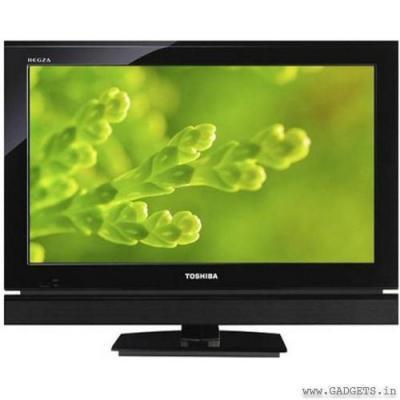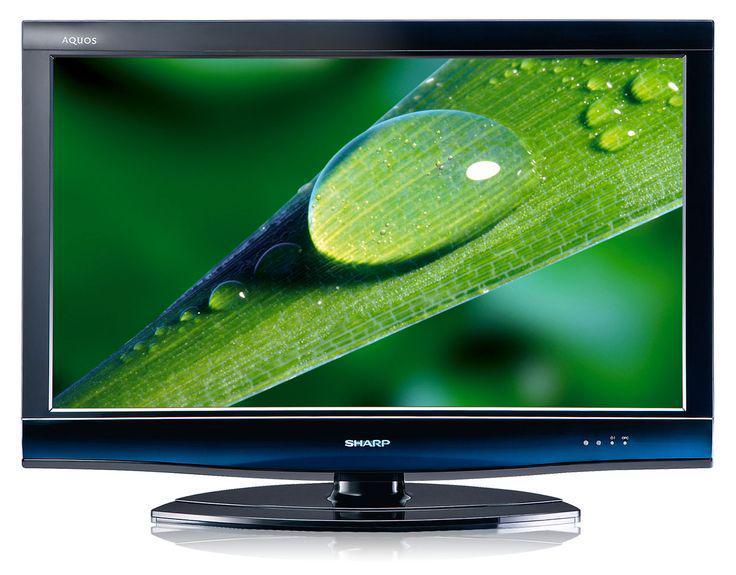The first image is the image on the left, the second image is the image on the right. For the images shown, is this caption "The TV on the right is viewed head-on, and the TV on the left is displayed at an angle." true? Answer yes or no. No. 